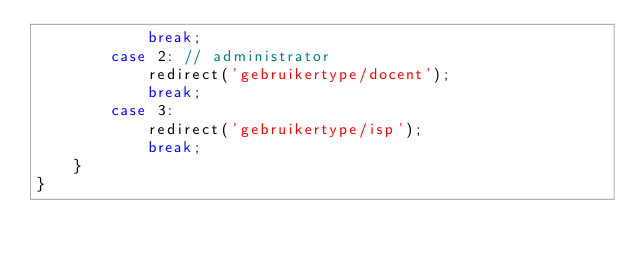Convert code to text. <code><loc_0><loc_0><loc_500><loc_500><_PHP_>            break;
        case 2: // administrator
            redirect('gebruikertype/docent');
            break;
        case 3:
            redirect('gebruikertype/isp');
            break;
    }
}</code> 